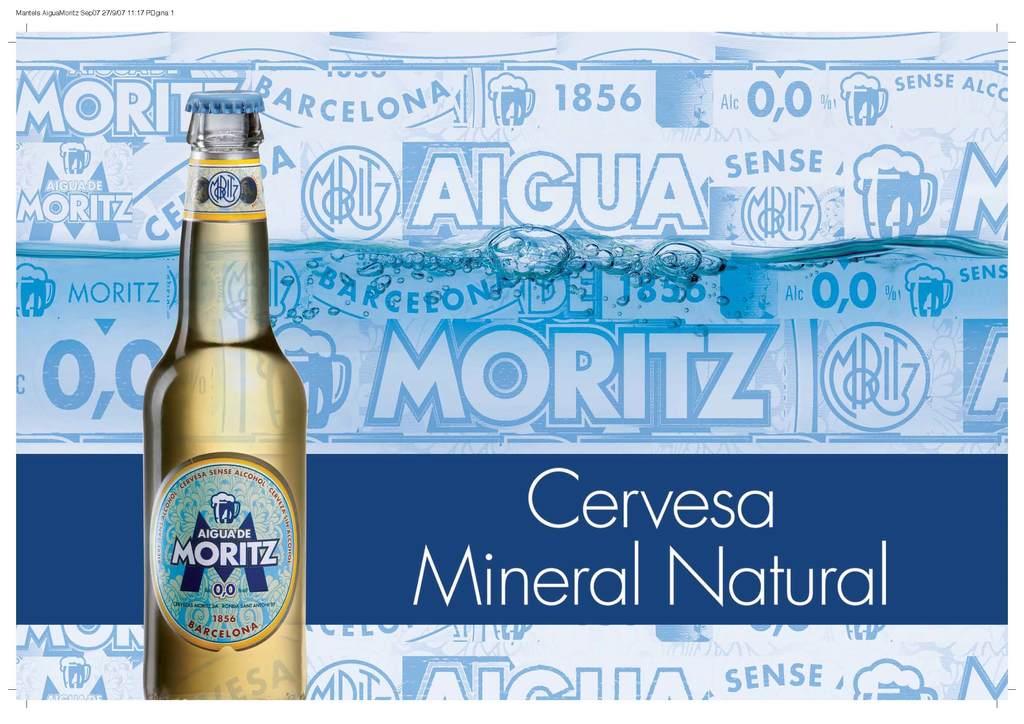What is the last word in the advertisement?
Keep it short and to the point. Natural. What type of drink is this?
Provide a succinct answer. Beer. 